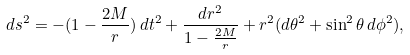Convert formula to latex. <formula><loc_0><loc_0><loc_500><loc_500>d s ^ { 2 } = - ( 1 - \frac { 2 M } { r } ) \, d t ^ { 2 } + \frac { d r ^ { 2 } } { 1 - \frac { 2 M } { r } } + r ^ { 2 } ( d \theta ^ { 2 } + \sin ^ { 2 } \theta \, d \phi ^ { 2 } ) ,</formula> 